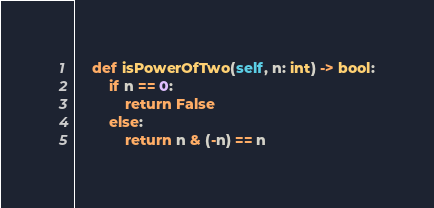<code> <loc_0><loc_0><loc_500><loc_500><_Python_>    def isPowerOfTwo(self, n: int) -> bool:
        if n == 0:
            return False
        else:
            return n & (-n) == n</code> 